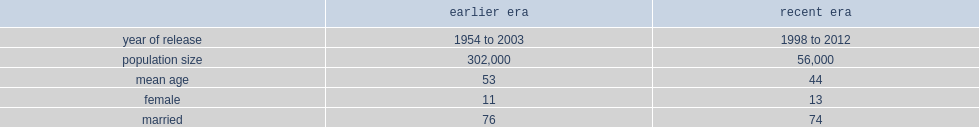What's the number of health indicators described for earlier era of regular force veterans who were released between 1954 and 2003? 302000.0. What's the number of health indicators described for recent era of regular force veterans who were released between 1998 and 2012? 56000.0. 